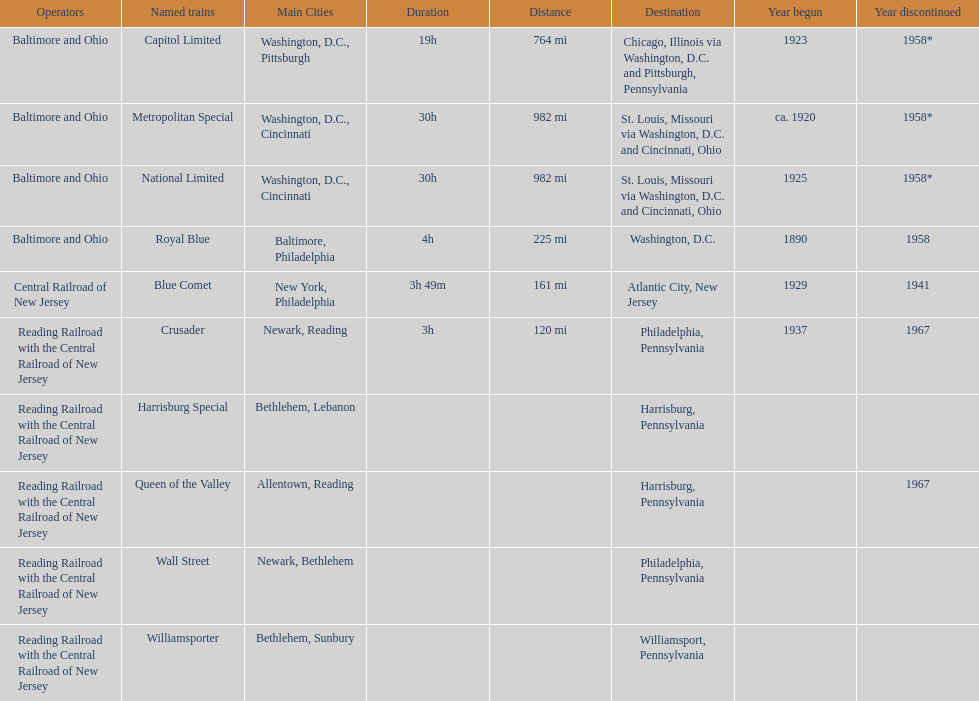What is the total number of year begun? 6. Would you mind parsing the complete table? {'header': ['Operators', 'Named trains', 'Main Cities', 'Duration', 'Distance', 'Destination', 'Year begun', 'Year discontinued'], 'rows': [['Baltimore and Ohio', 'Capitol Limited', 'Washington, D.C., Pittsburgh', '19h', '764 mi', 'Chicago, Illinois via Washington, D.C. and Pittsburgh, Pennsylvania', '1923', '1958*'], ['Baltimore and Ohio', 'Metropolitan Special', 'Washington, D.C., Cincinnati', '30h', '982 mi', 'St. Louis, Missouri via Washington, D.C. and Cincinnati, Ohio', 'ca. 1920', '1958*'], ['Baltimore and Ohio', 'National Limited', 'Washington, D.C., Cincinnati', '30h', '982 mi', 'St. Louis, Missouri via Washington, D.C. and Cincinnati, Ohio', '1925', '1958*'], ['Baltimore and Ohio', 'Royal Blue', 'Baltimore, Philadelphia', '4h', '225 mi', 'Washington, D.C.', '1890', '1958'], ['Central Railroad of New Jersey', 'Blue Comet', 'New York, Philadelphia', '3h 49m', '161 mi', 'Atlantic City, New Jersey', '1929', '1941'], ['Reading Railroad with the Central Railroad of New Jersey', 'Crusader', 'Newark, Reading', '3h', '120 mi', 'Philadelphia, Pennsylvania', '1937', '1967'], ['Reading Railroad with the Central Railroad of New Jersey', 'Harrisburg Special', 'Bethlehem, Lebanon', '', '', 'Harrisburg, Pennsylvania', '', ''], ['Reading Railroad with the Central Railroad of New Jersey', 'Queen of the Valley', 'Allentown, Reading', '', '', 'Harrisburg, Pennsylvania', '', '1967'], ['Reading Railroad with the Central Railroad of New Jersey', 'Wall Street', 'Newark, Bethlehem', '', '', 'Philadelphia, Pennsylvania', '', ''], ['Reading Railroad with the Central Railroad of New Jersey', 'Williamsporter', 'Bethlehem, Sunbury', '', '', 'Williamsport, Pennsylvania', '', '']]} 